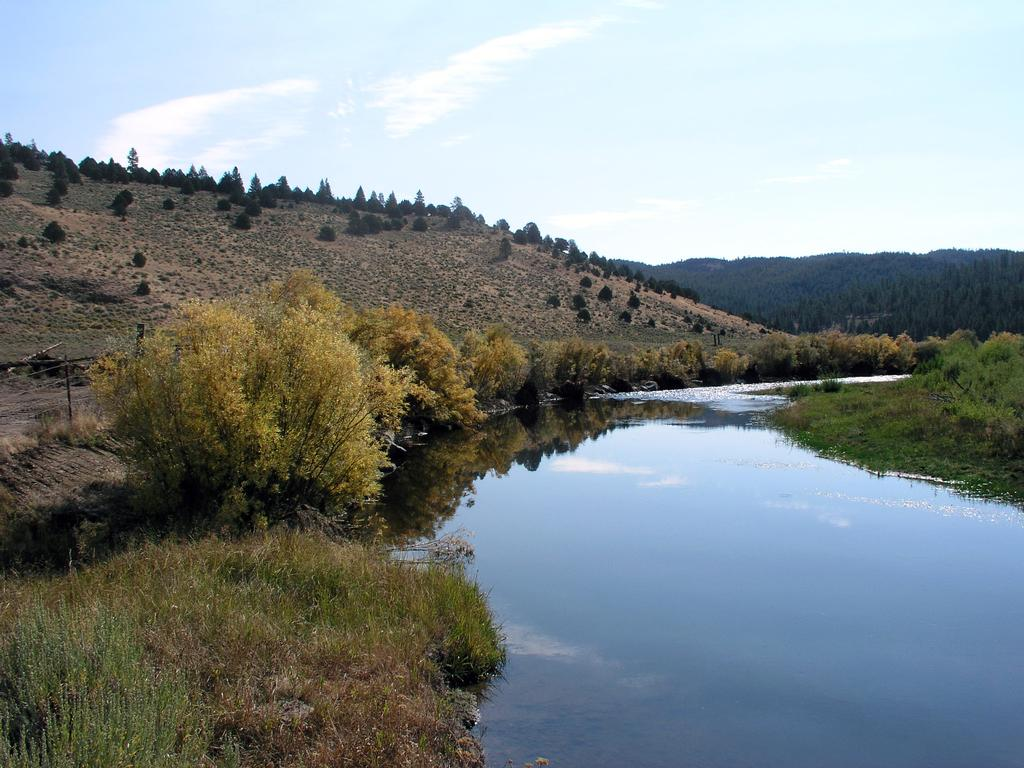What is the main subject of the image? The main subject of the image is a river flowing. What can be seen in the background of the image? There is a mountain in the background of the image. What is visible at the top of the image? The sky is visible at the top of the image. What type of cup can be seen on the wrist of the person in the image? There is no person or cup present in the image; it depicts a river flowing with a mountain in the background and the sky visible at the top. 